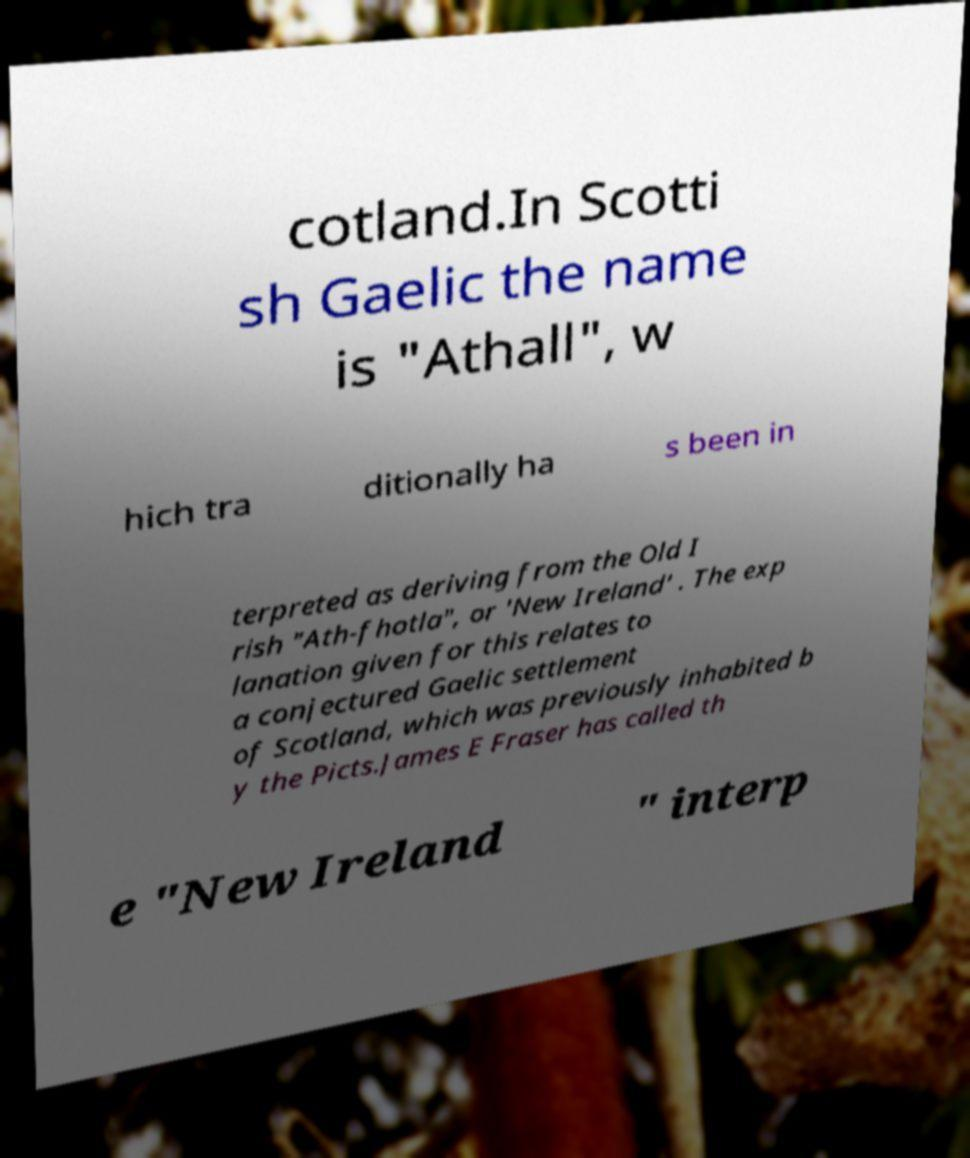Please identify and transcribe the text found in this image. cotland.In Scotti sh Gaelic the name is "Athall", w hich tra ditionally ha s been in terpreted as deriving from the Old I rish "Ath-fhotla", or 'New Ireland' . The exp lanation given for this relates to a conjectured Gaelic settlement of Scotland, which was previously inhabited b y the Picts.James E Fraser has called th e "New Ireland " interp 